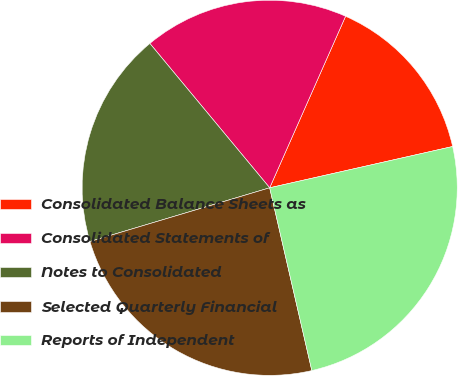Convert chart. <chart><loc_0><loc_0><loc_500><loc_500><pie_chart><fcel>Consolidated Balance Sheets as<fcel>Consolidated Statements of<fcel>Notes to Consolidated<fcel>Selected Quarterly Financial<fcel>Reports of Independent<nl><fcel>14.84%<fcel>17.66%<fcel>18.6%<fcel>23.99%<fcel>24.93%<nl></chart> 